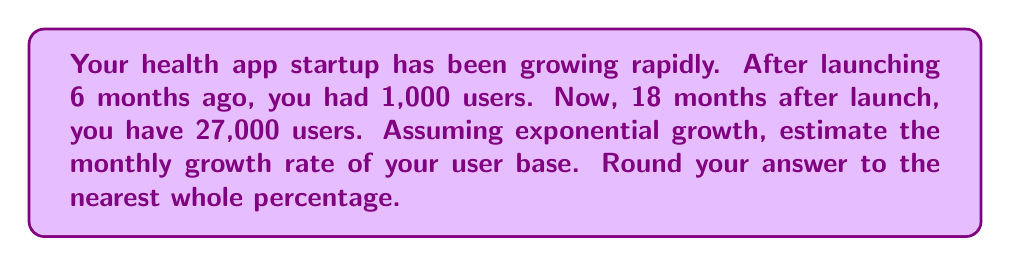Teach me how to tackle this problem. Let's approach this step-by-step using an exponential growth model:

1) The exponential growth function is given by: $N(t) = N_0 \cdot (1+r)^t$
   Where $N(t)$ is the number of users at time $t$, $N_0$ is the initial number of users,
   $r$ is the monthly growth rate, and $t$ is the number of months.

2) We know:
   - Initial users (6 months ago): $N_0 = 1,000$
   - Current users (18 months after launch): $N(12) = 27,000$ (as 18 - 6 = 12 months have passed)
   - Time period: $t = 12$ months

3) Let's plug these into our equation:
   $27,000 = 1,000 \cdot (1+r)^{12}$

4) Divide both sides by 1,000:
   $27 = (1+r)^{12}$

5) Take the 12th root of both sides:
   $\sqrt[12]{27} = 1+r$

6) Subtract 1 from both sides:
   $\sqrt[12]{27} - 1 = r$

7) Calculate:
   $r = \sqrt[12]{27} - 1 \approx 0.3486 = 34.86\%$

8) Rounding to the nearest whole percentage:
   $r \approx 35\%$
Answer: 35% 